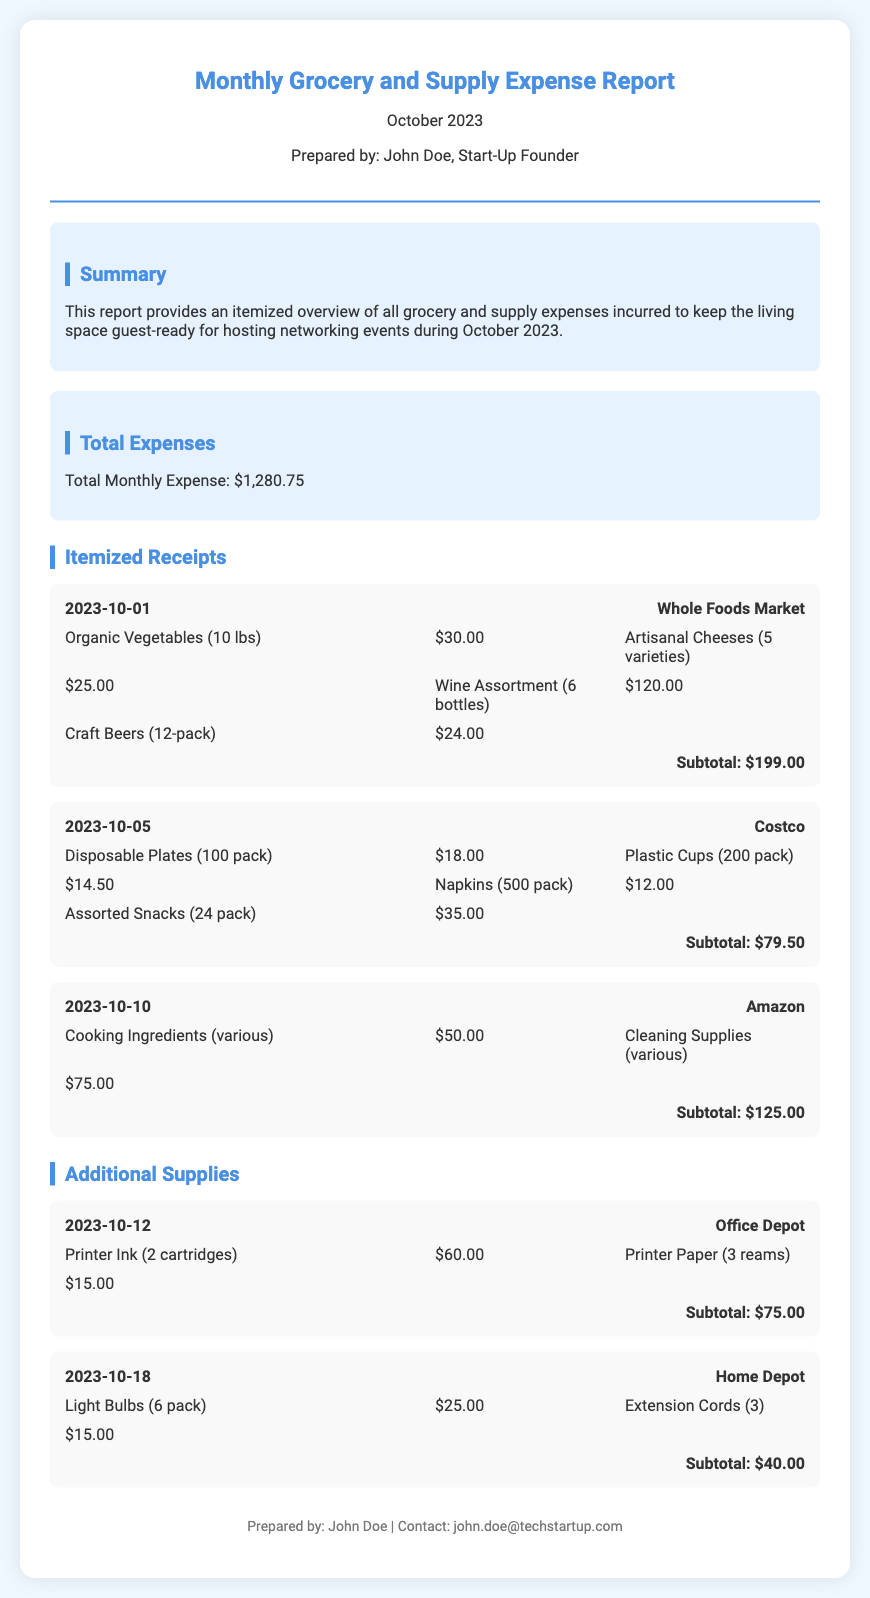What is the total monthly expense? The total monthly expense is listed in the document as $1,280.75.
Answer: $1,280.75 Who prepared the report? The report states it was prepared by John Doe.
Answer: John Doe What store was visited on October 1, 2023? The store name referenced for that date is Whole Foods Market.
Answer: Whole Foods Market How much was spent on disposable plates? The expense for disposable plates is noted as $18.00.
Answer: $18.00 What is the subtotal for the receipt from Amazon? The subtotal for the Amazon receipt totals $125.00.
Answer: $125.00 How many types of artisanal cheeses were purchased? The document specifies that 5 varieties of artisanal cheeses were purchased.
Answer: 5 varieties What item was bought from Office Depot? The item bought from Office Depot includes printer ink and paper.
Answer: Printer Ink (2 cartridges) and Printer Paper (3 reams) What is the date of the Home Depot purchase? The purchase date from Home Depot is provided as October 18, 2023.
Answer: October 18, 2023 What category of expenses does this report summarize? The report summarizes grocery and supply expenses.
Answer: Grocery and supply expenses 